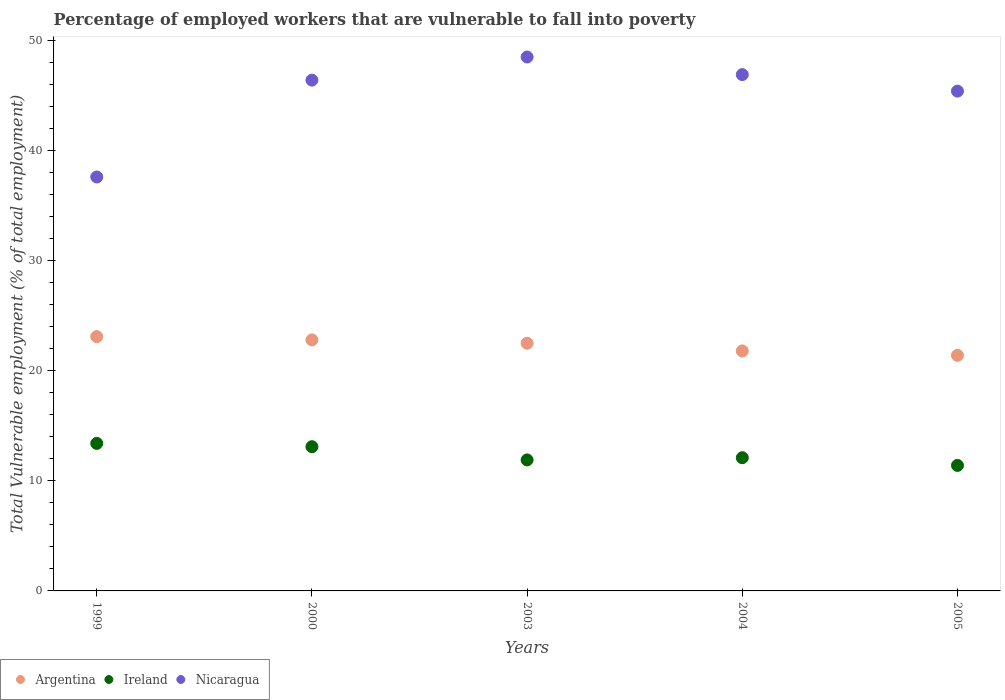What is the percentage of employed workers who are vulnerable to fall into poverty in Ireland in 2004?
Give a very brief answer. 12.1. Across all years, what is the maximum percentage of employed workers who are vulnerable to fall into poverty in Argentina?
Ensure brevity in your answer.  23.1. Across all years, what is the minimum percentage of employed workers who are vulnerable to fall into poverty in Argentina?
Provide a succinct answer. 21.4. In which year was the percentage of employed workers who are vulnerable to fall into poverty in Argentina maximum?
Give a very brief answer. 1999. In which year was the percentage of employed workers who are vulnerable to fall into poverty in Argentina minimum?
Ensure brevity in your answer.  2005. What is the total percentage of employed workers who are vulnerable to fall into poverty in Ireland in the graph?
Your response must be concise. 61.9. What is the difference between the percentage of employed workers who are vulnerable to fall into poverty in Argentina in 1999 and that in 2003?
Ensure brevity in your answer.  0.6. What is the difference between the percentage of employed workers who are vulnerable to fall into poverty in Ireland in 2004 and the percentage of employed workers who are vulnerable to fall into poverty in Argentina in 2003?
Make the answer very short. -10.4. What is the average percentage of employed workers who are vulnerable to fall into poverty in Argentina per year?
Your answer should be very brief. 22.32. In the year 1999, what is the difference between the percentage of employed workers who are vulnerable to fall into poverty in Ireland and percentage of employed workers who are vulnerable to fall into poverty in Nicaragua?
Provide a short and direct response. -24.2. What is the ratio of the percentage of employed workers who are vulnerable to fall into poverty in Nicaragua in 2000 to that in 2003?
Provide a succinct answer. 0.96. Is the difference between the percentage of employed workers who are vulnerable to fall into poverty in Ireland in 2000 and 2005 greater than the difference between the percentage of employed workers who are vulnerable to fall into poverty in Nicaragua in 2000 and 2005?
Keep it short and to the point. Yes. What is the difference between the highest and the second highest percentage of employed workers who are vulnerable to fall into poverty in Ireland?
Make the answer very short. 0.3. Is it the case that in every year, the sum of the percentage of employed workers who are vulnerable to fall into poverty in Nicaragua and percentage of employed workers who are vulnerable to fall into poverty in Argentina  is greater than the percentage of employed workers who are vulnerable to fall into poverty in Ireland?
Give a very brief answer. Yes. Does the percentage of employed workers who are vulnerable to fall into poverty in Ireland monotonically increase over the years?
Provide a succinct answer. No. How many years are there in the graph?
Give a very brief answer. 5. What is the difference between two consecutive major ticks on the Y-axis?
Keep it short and to the point. 10. Where does the legend appear in the graph?
Ensure brevity in your answer.  Bottom left. What is the title of the graph?
Give a very brief answer. Percentage of employed workers that are vulnerable to fall into poverty. What is the label or title of the Y-axis?
Your answer should be compact. Total Vulnerable employment (% of total employment). What is the Total Vulnerable employment (% of total employment) in Argentina in 1999?
Your answer should be compact. 23.1. What is the Total Vulnerable employment (% of total employment) in Ireland in 1999?
Give a very brief answer. 13.4. What is the Total Vulnerable employment (% of total employment) in Nicaragua in 1999?
Keep it short and to the point. 37.6. What is the Total Vulnerable employment (% of total employment) of Argentina in 2000?
Make the answer very short. 22.8. What is the Total Vulnerable employment (% of total employment) of Ireland in 2000?
Your response must be concise. 13.1. What is the Total Vulnerable employment (% of total employment) of Nicaragua in 2000?
Offer a very short reply. 46.4. What is the Total Vulnerable employment (% of total employment) of Argentina in 2003?
Provide a short and direct response. 22.5. What is the Total Vulnerable employment (% of total employment) in Ireland in 2003?
Keep it short and to the point. 11.9. What is the Total Vulnerable employment (% of total employment) of Nicaragua in 2003?
Make the answer very short. 48.5. What is the Total Vulnerable employment (% of total employment) of Argentina in 2004?
Provide a succinct answer. 21.8. What is the Total Vulnerable employment (% of total employment) in Ireland in 2004?
Your answer should be compact. 12.1. What is the Total Vulnerable employment (% of total employment) in Nicaragua in 2004?
Keep it short and to the point. 46.9. What is the Total Vulnerable employment (% of total employment) of Argentina in 2005?
Give a very brief answer. 21.4. What is the Total Vulnerable employment (% of total employment) of Ireland in 2005?
Provide a succinct answer. 11.4. What is the Total Vulnerable employment (% of total employment) in Nicaragua in 2005?
Your answer should be compact. 45.4. Across all years, what is the maximum Total Vulnerable employment (% of total employment) of Argentina?
Your answer should be compact. 23.1. Across all years, what is the maximum Total Vulnerable employment (% of total employment) of Ireland?
Your answer should be compact. 13.4. Across all years, what is the maximum Total Vulnerable employment (% of total employment) of Nicaragua?
Offer a terse response. 48.5. Across all years, what is the minimum Total Vulnerable employment (% of total employment) of Argentina?
Ensure brevity in your answer.  21.4. Across all years, what is the minimum Total Vulnerable employment (% of total employment) in Ireland?
Give a very brief answer. 11.4. Across all years, what is the minimum Total Vulnerable employment (% of total employment) in Nicaragua?
Your answer should be very brief. 37.6. What is the total Total Vulnerable employment (% of total employment) in Argentina in the graph?
Your answer should be very brief. 111.6. What is the total Total Vulnerable employment (% of total employment) in Ireland in the graph?
Give a very brief answer. 61.9. What is the total Total Vulnerable employment (% of total employment) of Nicaragua in the graph?
Provide a succinct answer. 224.8. What is the difference between the Total Vulnerable employment (% of total employment) of Argentina in 1999 and that in 2003?
Your answer should be very brief. 0.6. What is the difference between the Total Vulnerable employment (% of total employment) in Ireland in 1999 and that in 2003?
Give a very brief answer. 1.5. What is the difference between the Total Vulnerable employment (% of total employment) of Argentina in 1999 and that in 2004?
Your response must be concise. 1.3. What is the difference between the Total Vulnerable employment (% of total employment) in Argentina in 1999 and that in 2005?
Offer a very short reply. 1.7. What is the difference between the Total Vulnerable employment (% of total employment) of Argentina in 2000 and that in 2003?
Provide a short and direct response. 0.3. What is the difference between the Total Vulnerable employment (% of total employment) in Ireland in 2000 and that in 2003?
Provide a succinct answer. 1.2. What is the difference between the Total Vulnerable employment (% of total employment) of Argentina in 2000 and that in 2004?
Provide a short and direct response. 1. What is the difference between the Total Vulnerable employment (% of total employment) in Nicaragua in 2000 and that in 2004?
Keep it short and to the point. -0.5. What is the difference between the Total Vulnerable employment (% of total employment) of Argentina in 2000 and that in 2005?
Give a very brief answer. 1.4. What is the difference between the Total Vulnerable employment (% of total employment) in Argentina in 2003 and that in 2004?
Provide a succinct answer. 0.7. What is the difference between the Total Vulnerable employment (% of total employment) of Nicaragua in 2003 and that in 2004?
Ensure brevity in your answer.  1.6. What is the difference between the Total Vulnerable employment (% of total employment) of Nicaragua in 2003 and that in 2005?
Your response must be concise. 3.1. What is the difference between the Total Vulnerable employment (% of total employment) in Ireland in 2004 and that in 2005?
Your response must be concise. 0.7. What is the difference between the Total Vulnerable employment (% of total employment) of Nicaragua in 2004 and that in 2005?
Provide a short and direct response. 1.5. What is the difference between the Total Vulnerable employment (% of total employment) in Argentina in 1999 and the Total Vulnerable employment (% of total employment) in Ireland in 2000?
Offer a very short reply. 10. What is the difference between the Total Vulnerable employment (% of total employment) of Argentina in 1999 and the Total Vulnerable employment (% of total employment) of Nicaragua in 2000?
Your answer should be compact. -23.3. What is the difference between the Total Vulnerable employment (% of total employment) of Ireland in 1999 and the Total Vulnerable employment (% of total employment) of Nicaragua in 2000?
Your answer should be very brief. -33. What is the difference between the Total Vulnerable employment (% of total employment) of Argentina in 1999 and the Total Vulnerable employment (% of total employment) of Ireland in 2003?
Make the answer very short. 11.2. What is the difference between the Total Vulnerable employment (% of total employment) of Argentina in 1999 and the Total Vulnerable employment (% of total employment) of Nicaragua in 2003?
Offer a very short reply. -25.4. What is the difference between the Total Vulnerable employment (% of total employment) of Ireland in 1999 and the Total Vulnerable employment (% of total employment) of Nicaragua in 2003?
Provide a succinct answer. -35.1. What is the difference between the Total Vulnerable employment (% of total employment) in Argentina in 1999 and the Total Vulnerable employment (% of total employment) in Ireland in 2004?
Offer a terse response. 11. What is the difference between the Total Vulnerable employment (% of total employment) in Argentina in 1999 and the Total Vulnerable employment (% of total employment) in Nicaragua in 2004?
Provide a short and direct response. -23.8. What is the difference between the Total Vulnerable employment (% of total employment) of Ireland in 1999 and the Total Vulnerable employment (% of total employment) of Nicaragua in 2004?
Ensure brevity in your answer.  -33.5. What is the difference between the Total Vulnerable employment (% of total employment) of Argentina in 1999 and the Total Vulnerable employment (% of total employment) of Ireland in 2005?
Your response must be concise. 11.7. What is the difference between the Total Vulnerable employment (% of total employment) in Argentina in 1999 and the Total Vulnerable employment (% of total employment) in Nicaragua in 2005?
Make the answer very short. -22.3. What is the difference between the Total Vulnerable employment (% of total employment) in Ireland in 1999 and the Total Vulnerable employment (% of total employment) in Nicaragua in 2005?
Your answer should be very brief. -32. What is the difference between the Total Vulnerable employment (% of total employment) of Argentina in 2000 and the Total Vulnerable employment (% of total employment) of Nicaragua in 2003?
Your response must be concise. -25.7. What is the difference between the Total Vulnerable employment (% of total employment) in Ireland in 2000 and the Total Vulnerable employment (% of total employment) in Nicaragua in 2003?
Keep it short and to the point. -35.4. What is the difference between the Total Vulnerable employment (% of total employment) in Argentina in 2000 and the Total Vulnerable employment (% of total employment) in Nicaragua in 2004?
Offer a very short reply. -24.1. What is the difference between the Total Vulnerable employment (% of total employment) in Ireland in 2000 and the Total Vulnerable employment (% of total employment) in Nicaragua in 2004?
Keep it short and to the point. -33.8. What is the difference between the Total Vulnerable employment (% of total employment) in Argentina in 2000 and the Total Vulnerable employment (% of total employment) in Nicaragua in 2005?
Your answer should be very brief. -22.6. What is the difference between the Total Vulnerable employment (% of total employment) in Ireland in 2000 and the Total Vulnerable employment (% of total employment) in Nicaragua in 2005?
Keep it short and to the point. -32.3. What is the difference between the Total Vulnerable employment (% of total employment) of Argentina in 2003 and the Total Vulnerable employment (% of total employment) of Ireland in 2004?
Your answer should be very brief. 10.4. What is the difference between the Total Vulnerable employment (% of total employment) in Argentina in 2003 and the Total Vulnerable employment (% of total employment) in Nicaragua in 2004?
Provide a succinct answer. -24.4. What is the difference between the Total Vulnerable employment (% of total employment) in Ireland in 2003 and the Total Vulnerable employment (% of total employment) in Nicaragua in 2004?
Your response must be concise. -35. What is the difference between the Total Vulnerable employment (% of total employment) in Argentina in 2003 and the Total Vulnerable employment (% of total employment) in Nicaragua in 2005?
Give a very brief answer. -22.9. What is the difference between the Total Vulnerable employment (% of total employment) in Ireland in 2003 and the Total Vulnerable employment (% of total employment) in Nicaragua in 2005?
Offer a terse response. -33.5. What is the difference between the Total Vulnerable employment (% of total employment) in Argentina in 2004 and the Total Vulnerable employment (% of total employment) in Ireland in 2005?
Provide a succinct answer. 10.4. What is the difference between the Total Vulnerable employment (% of total employment) in Argentina in 2004 and the Total Vulnerable employment (% of total employment) in Nicaragua in 2005?
Your answer should be compact. -23.6. What is the difference between the Total Vulnerable employment (% of total employment) of Ireland in 2004 and the Total Vulnerable employment (% of total employment) of Nicaragua in 2005?
Your answer should be very brief. -33.3. What is the average Total Vulnerable employment (% of total employment) of Argentina per year?
Give a very brief answer. 22.32. What is the average Total Vulnerable employment (% of total employment) in Ireland per year?
Give a very brief answer. 12.38. What is the average Total Vulnerable employment (% of total employment) of Nicaragua per year?
Make the answer very short. 44.96. In the year 1999, what is the difference between the Total Vulnerable employment (% of total employment) in Argentina and Total Vulnerable employment (% of total employment) in Nicaragua?
Your response must be concise. -14.5. In the year 1999, what is the difference between the Total Vulnerable employment (% of total employment) in Ireland and Total Vulnerable employment (% of total employment) in Nicaragua?
Make the answer very short. -24.2. In the year 2000, what is the difference between the Total Vulnerable employment (% of total employment) in Argentina and Total Vulnerable employment (% of total employment) in Nicaragua?
Make the answer very short. -23.6. In the year 2000, what is the difference between the Total Vulnerable employment (% of total employment) of Ireland and Total Vulnerable employment (% of total employment) of Nicaragua?
Ensure brevity in your answer.  -33.3. In the year 2003, what is the difference between the Total Vulnerable employment (% of total employment) of Ireland and Total Vulnerable employment (% of total employment) of Nicaragua?
Keep it short and to the point. -36.6. In the year 2004, what is the difference between the Total Vulnerable employment (% of total employment) in Argentina and Total Vulnerable employment (% of total employment) in Nicaragua?
Provide a short and direct response. -25.1. In the year 2004, what is the difference between the Total Vulnerable employment (% of total employment) of Ireland and Total Vulnerable employment (% of total employment) of Nicaragua?
Your answer should be very brief. -34.8. In the year 2005, what is the difference between the Total Vulnerable employment (% of total employment) in Ireland and Total Vulnerable employment (% of total employment) in Nicaragua?
Provide a succinct answer. -34. What is the ratio of the Total Vulnerable employment (% of total employment) in Argentina in 1999 to that in 2000?
Your response must be concise. 1.01. What is the ratio of the Total Vulnerable employment (% of total employment) in Ireland in 1999 to that in 2000?
Keep it short and to the point. 1.02. What is the ratio of the Total Vulnerable employment (% of total employment) of Nicaragua in 1999 to that in 2000?
Your answer should be compact. 0.81. What is the ratio of the Total Vulnerable employment (% of total employment) in Argentina in 1999 to that in 2003?
Your response must be concise. 1.03. What is the ratio of the Total Vulnerable employment (% of total employment) in Ireland in 1999 to that in 2003?
Offer a terse response. 1.13. What is the ratio of the Total Vulnerable employment (% of total employment) in Nicaragua in 1999 to that in 2003?
Provide a short and direct response. 0.78. What is the ratio of the Total Vulnerable employment (% of total employment) of Argentina in 1999 to that in 2004?
Provide a short and direct response. 1.06. What is the ratio of the Total Vulnerable employment (% of total employment) in Ireland in 1999 to that in 2004?
Provide a short and direct response. 1.11. What is the ratio of the Total Vulnerable employment (% of total employment) in Nicaragua in 1999 to that in 2004?
Provide a short and direct response. 0.8. What is the ratio of the Total Vulnerable employment (% of total employment) of Argentina in 1999 to that in 2005?
Your answer should be very brief. 1.08. What is the ratio of the Total Vulnerable employment (% of total employment) of Ireland in 1999 to that in 2005?
Ensure brevity in your answer.  1.18. What is the ratio of the Total Vulnerable employment (% of total employment) of Nicaragua in 1999 to that in 2005?
Give a very brief answer. 0.83. What is the ratio of the Total Vulnerable employment (% of total employment) in Argentina in 2000 to that in 2003?
Ensure brevity in your answer.  1.01. What is the ratio of the Total Vulnerable employment (% of total employment) of Ireland in 2000 to that in 2003?
Your answer should be very brief. 1.1. What is the ratio of the Total Vulnerable employment (% of total employment) in Nicaragua in 2000 to that in 2003?
Your response must be concise. 0.96. What is the ratio of the Total Vulnerable employment (% of total employment) of Argentina in 2000 to that in 2004?
Your response must be concise. 1.05. What is the ratio of the Total Vulnerable employment (% of total employment) of Ireland in 2000 to that in 2004?
Your answer should be compact. 1.08. What is the ratio of the Total Vulnerable employment (% of total employment) in Nicaragua in 2000 to that in 2004?
Offer a very short reply. 0.99. What is the ratio of the Total Vulnerable employment (% of total employment) of Argentina in 2000 to that in 2005?
Your response must be concise. 1.07. What is the ratio of the Total Vulnerable employment (% of total employment) of Ireland in 2000 to that in 2005?
Offer a very short reply. 1.15. What is the ratio of the Total Vulnerable employment (% of total employment) in Nicaragua in 2000 to that in 2005?
Offer a very short reply. 1.02. What is the ratio of the Total Vulnerable employment (% of total employment) in Argentina in 2003 to that in 2004?
Give a very brief answer. 1.03. What is the ratio of the Total Vulnerable employment (% of total employment) in Ireland in 2003 to that in 2004?
Make the answer very short. 0.98. What is the ratio of the Total Vulnerable employment (% of total employment) in Nicaragua in 2003 to that in 2004?
Offer a terse response. 1.03. What is the ratio of the Total Vulnerable employment (% of total employment) in Argentina in 2003 to that in 2005?
Provide a succinct answer. 1.05. What is the ratio of the Total Vulnerable employment (% of total employment) of Ireland in 2003 to that in 2005?
Keep it short and to the point. 1.04. What is the ratio of the Total Vulnerable employment (% of total employment) of Nicaragua in 2003 to that in 2005?
Make the answer very short. 1.07. What is the ratio of the Total Vulnerable employment (% of total employment) of Argentina in 2004 to that in 2005?
Keep it short and to the point. 1.02. What is the ratio of the Total Vulnerable employment (% of total employment) in Ireland in 2004 to that in 2005?
Your response must be concise. 1.06. What is the ratio of the Total Vulnerable employment (% of total employment) of Nicaragua in 2004 to that in 2005?
Provide a succinct answer. 1.03. What is the difference between the highest and the second highest Total Vulnerable employment (% of total employment) in Argentina?
Your answer should be very brief. 0.3. What is the difference between the highest and the second highest Total Vulnerable employment (% of total employment) in Ireland?
Your answer should be very brief. 0.3. What is the difference between the highest and the second highest Total Vulnerable employment (% of total employment) of Nicaragua?
Offer a terse response. 1.6. What is the difference between the highest and the lowest Total Vulnerable employment (% of total employment) in Ireland?
Keep it short and to the point. 2. 